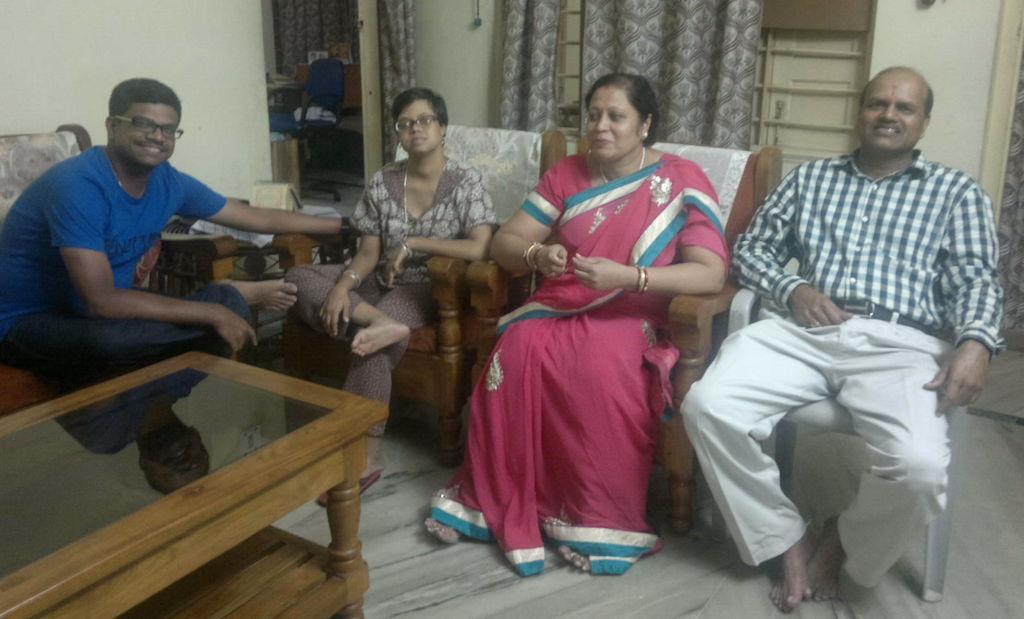Please provide a concise description of this image. Four persons are sitting in chair and there is a table in front of them. 